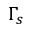<formula> <loc_0><loc_0><loc_500><loc_500>\Gamma _ { s }</formula> 